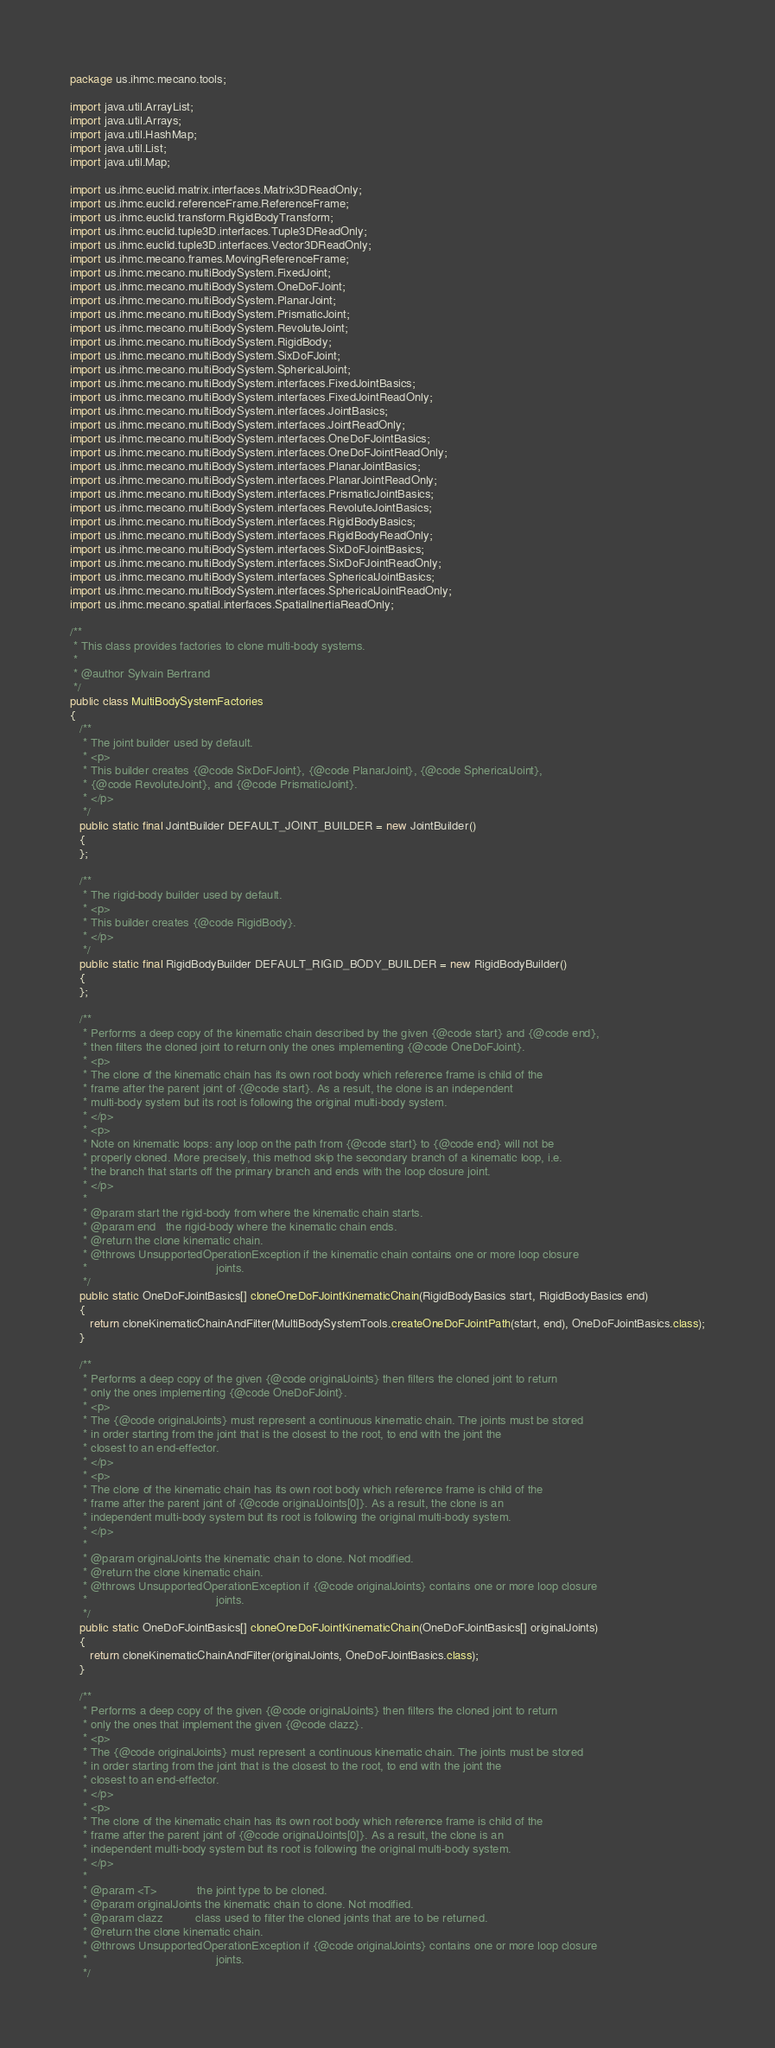<code> <loc_0><loc_0><loc_500><loc_500><_Java_>package us.ihmc.mecano.tools;

import java.util.ArrayList;
import java.util.Arrays;
import java.util.HashMap;
import java.util.List;
import java.util.Map;

import us.ihmc.euclid.matrix.interfaces.Matrix3DReadOnly;
import us.ihmc.euclid.referenceFrame.ReferenceFrame;
import us.ihmc.euclid.transform.RigidBodyTransform;
import us.ihmc.euclid.tuple3D.interfaces.Tuple3DReadOnly;
import us.ihmc.euclid.tuple3D.interfaces.Vector3DReadOnly;
import us.ihmc.mecano.frames.MovingReferenceFrame;
import us.ihmc.mecano.multiBodySystem.FixedJoint;
import us.ihmc.mecano.multiBodySystem.OneDoFJoint;
import us.ihmc.mecano.multiBodySystem.PlanarJoint;
import us.ihmc.mecano.multiBodySystem.PrismaticJoint;
import us.ihmc.mecano.multiBodySystem.RevoluteJoint;
import us.ihmc.mecano.multiBodySystem.RigidBody;
import us.ihmc.mecano.multiBodySystem.SixDoFJoint;
import us.ihmc.mecano.multiBodySystem.SphericalJoint;
import us.ihmc.mecano.multiBodySystem.interfaces.FixedJointBasics;
import us.ihmc.mecano.multiBodySystem.interfaces.FixedJointReadOnly;
import us.ihmc.mecano.multiBodySystem.interfaces.JointBasics;
import us.ihmc.mecano.multiBodySystem.interfaces.JointReadOnly;
import us.ihmc.mecano.multiBodySystem.interfaces.OneDoFJointBasics;
import us.ihmc.mecano.multiBodySystem.interfaces.OneDoFJointReadOnly;
import us.ihmc.mecano.multiBodySystem.interfaces.PlanarJointBasics;
import us.ihmc.mecano.multiBodySystem.interfaces.PlanarJointReadOnly;
import us.ihmc.mecano.multiBodySystem.interfaces.PrismaticJointBasics;
import us.ihmc.mecano.multiBodySystem.interfaces.RevoluteJointBasics;
import us.ihmc.mecano.multiBodySystem.interfaces.RigidBodyBasics;
import us.ihmc.mecano.multiBodySystem.interfaces.RigidBodyReadOnly;
import us.ihmc.mecano.multiBodySystem.interfaces.SixDoFJointBasics;
import us.ihmc.mecano.multiBodySystem.interfaces.SixDoFJointReadOnly;
import us.ihmc.mecano.multiBodySystem.interfaces.SphericalJointBasics;
import us.ihmc.mecano.multiBodySystem.interfaces.SphericalJointReadOnly;
import us.ihmc.mecano.spatial.interfaces.SpatialInertiaReadOnly;

/**
 * This class provides factories to clone multi-body systems.
 *
 * @author Sylvain Bertrand
 */
public class MultiBodySystemFactories
{
   /**
    * The joint builder used by default.
    * <p>
    * This builder creates {@code SixDoFJoint}, {@code PlanarJoint}, {@code SphericalJoint},
    * {@code RevoluteJoint}, and {@code PrismaticJoint}.
    * </p>
    */
   public static final JointBuilder DEFAULT_JOINT_BUILDER = new JointBuilder()
   {
   };

   /**
    * The rigid-body builder used by default.
    * <p>
    * This builder creates {@code RigidBody}.
    * </p>
    */
   public static final RigidBodyBuilder DEFAULT_RIGID_BODY_BUILDER = new RigidBodyBuilder()
   {
   };

   /**
    * Performs a deep copy of the kinematic chain described by the given {@code start} and {@code end},
    * then filters the cloned joint to return only the ones implementing {@code OneDoFJoint}.
    * <p>
    * The clone of the kinematic chain has its own root body which reference frame is child of the
    * frame after the parent joint of {@code start}. As a result, the clone is an independent
    * multi-body system but its root is following the original multi-body system.
    * </p>
    * <p>
    * Note on kinematic loops: any loop on the path from {@code start} to {@code end} will not be
    * properly cloned. More precisely, this method skip the secondary branch of a kinematic loop, i.e.
    * the branch that starts off the primary branch and ends with the loop closure joint.
    * </p>
    *
    * @param start the rigid-body from where the kinematic chain starts.
    * @param end   the rigid-body where the kinematic chain ends.
    * @return the clone kinematic chain.
    * @throws UnsupportedOperationException if the kinematic chain contains one or more loop closure
    *                                       joints.
    */
   public static OneDoFJointBasics[] cloneOneDoFJointKinematicChain(RigidBodyBasics start, RigidBodyBasics end)
   {
      return cloneKinematicChainAndFilter(MultiBodySystemTools.createOneDoFJointPath(start, end), OneDoFJointBasics.class);
   }

   /**
    * Performs a deep copy of the given {@code originalJoints} then filters the cloned joint to return
    * only the ones implementing {@code OneDoFJoint}.
    * <p>
    * The {@code originalJoints} must represent a continuous kinematic chain. The joints must be stored
    * in order starting from the joint that is the closest to the root, to end with the joint the
    * closest to an end-effector.
    * </p>
    * <p>
    * The clone of the kinematic chain has its own root body which reference frame is child of the
    * frame after the parent joint of {@code originalJoints[0]}. As a result, the clone is an
    * independent multi-body system but its root is following the original multi-body system.
    * </p>
    *
    * @param originalJoints the kinematic chain to clone. Not modified.
    * @return the clone kinematic chain.
    * @throws UnsupportedOperationException if {@code originalJoints} contains one or more loop closure
    *                                       joints.
    */
   public static OneDoFJointBasics[] cloneOneDoFJointKinematicChain(OneDoFJointBasics[] originalJoints)
   {
      return cloneKinematicChainAndFilter(originalJoints, OneDoFJointBasics.class);
   }

   /**
    * Performs a deep copy of the given {@code originalJoints} then filters the cloned joint to return
    * only the ones that implement the given {@code clazz}.
    * <p>
    * The {@code originalJoints} must represent a continuous kinematic chain. The joints must be stored
    * in order starting from the joint that is the closest to the root, to end with the joint the
    * closest to an end-effector.
    * </p>
    * <p>
    * The clone of the kinematic chain has its own root body which reference frame is child of the
    * frame after the parent joint of {@code originalJoints[0]}. As a result, the clone is an
    * independent multi-body system but its root is following the original multi-body system.
    * </p>
    *
    * @param <T>            the joint type to be cloned.
    * @param originalJoints the kinematic chain to clone. Not modified.
    * @param clazz          class used to filter the cloned joints that are to be returned.
    * @return the clone kinematic chain.
    * @throws UnsupportedOperationException if {@code originalJoints} contains one or more loop closure
    *                                       joints.
    */</code> 